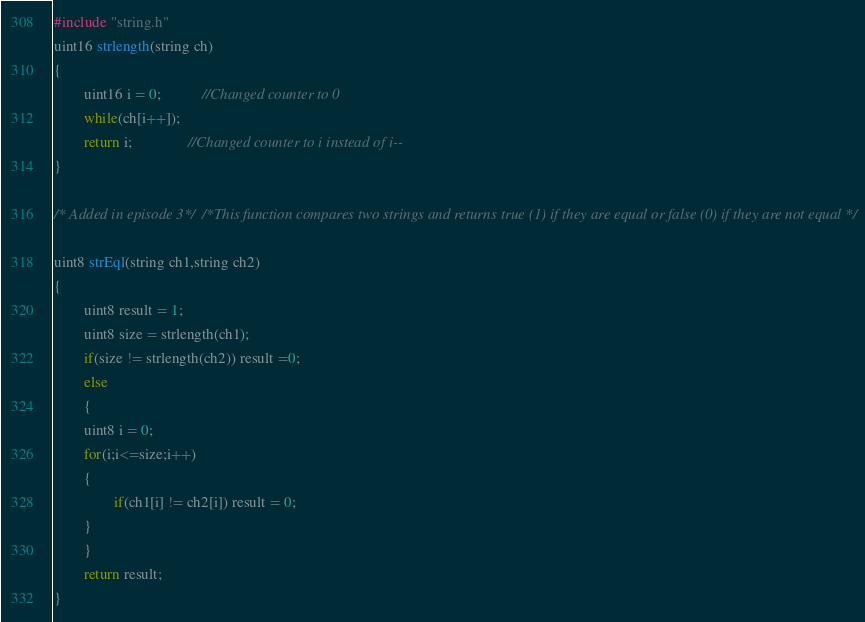Convert code to text. <code><loc_0><loc_0><loc_500><loc_500><_C_>#include "string.h"
uint16 strlength(string ch)
{
        uint16 i = 0;           //Changed counter to 0
        while(ch[i++]);  
        return i;               //Changed counter to i instead of i--
}

/* Added in episode 3*/ /*This function compares two strings and returns true (1) if they are equal or false (0) if they are not equal */

uint8 strEql(string ch1,string ch2)                     
{
        uint8 result = 1;
        uint8 size = strlength(ch1);
        if(size != strlength(ch2)) result =0;
        else 
        {
        uint8 i = 0;
        for(i;i<=size;i++)
        {
                if(ch1[i] != ch2[i]) result = 0;
        }
        }
        return result;
}

</code> 